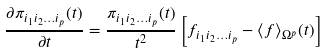Convert formula to latex. <formula><loc_0><loc_0><loc_500><loc_500>\frac { \partial \pi _ { i _ { 1 } i _ { 2 } \dots i _ { p } } ( t ) } { \partial t } = \frac { \pi _ { i _ { 1 } i _ { 2 } \dots i _ { p } } ( t ) } { t ^ { 2 } } \left [ f _ { i _ { 1 } i _ { 2 } \dots i _ { p } } - { \langle f \rangle } _ { \Omega ^ { p } } ( t ) \right ]</formula> 